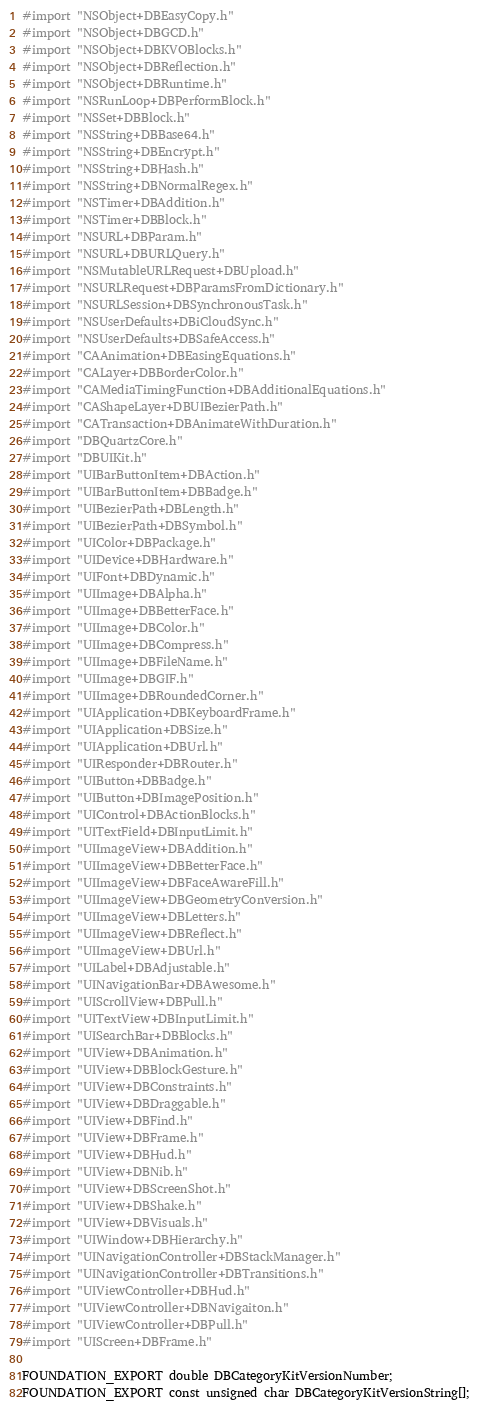<code> <loc_0><loc_0><loc_500><loc_500><_C_>#import "NSObject+DBEasyCopy.h"
#import "NSObject+DBGCD.h"
#import "NSObject+DBKVOBlocks.h"
#import "NSObject+DBReflection.h"
#import "NSObject+DBRuntime.h"
#import "NSRunLoop+DBPerformBlock.h"
#import "NSSet+DBBlock.h"
#import "NSString+DBBase64.h"
#import "NSString+DBEncrypt.h"
#import "NSString+DBHash.h"
#import "NSString+DBNormalRegex.h"
#import "NSTimer+DBAddition.h"
#import "NSTimer+DBBlock.h"
#import "NSURL+DBParam.h"
#import "NSURL+DBURLQuery.h"
#import "NSMutableURLRequest+DBUpload.h"
#import "NSURLRequest+DBParamsFromDictionary.h"
#import "NSURLSession+DBSynchronousTask.h"
#import "NSUserDefaults+DBiCloudSync.h"
#import "NSUserDefaults+DBSafeAccess.h"
#import "CAAnimation+DBEasingEquations.h"
#import "CALayer+DBBorderColor.h"
#import "CAMediaTimingFunction+DBAdditionalEquations.h"
#import "CAShapeLayer+DBUIBezierPath.h"
#import "CATransaction+DBAnimateWithDuration.h"
#import "DBQuartzCore.h"
#import "DBUIKit.h"
#import "UIBarButtonItem+DBAction.h"
#import "UIBarButtonItem+DBBadge.h"
#import "UIBezierPath+DBLength.h"
#import "UIBezierPath+DBSymbol.h"
#import "UIColor+DBPackage.h"
#import "UIDevice+DBHardware.h"
#import "UIFont+DBDynamic.h"
#import "UIImage+DBAlpha.h"
#import "UIImage+DBBetterFace.h"
#import "UIImage+DBColor.h"
#import "UIImage+DBCompress.h"
#import "UIImage+DBFileName.h"
#import "UIImage+DBGIF.h"
#import "UIImage+DBRoundedCorner.h"
#import "UIApplication+DBKeyboardFrame.h"
#import "UIApplication+DBSize.h"
#import "UIApplication+DBUrl.h"
#import "UIResponder+DBRouter.h"
#import "UIButton+DBBadge.h"
#import "UIButton+DBImagePosition.h"
#import "UIControl+DBActionBlocks.h"
#import "UITextField+DBInputLimit.h"
#import "UIImageView+DBAddition.h"
#import "UIImageView+DBBetterFace.h"
#import "UIImageView+DBFaceAwareFill.h"
#import "UIImageView+DBGeometryConversion.h"
#import "UIImageView+DBLetters.h"
#import "UIImageView+DBReflect.h"
#import "UIImageView+DBUrl.h"
#import "UILabel+DBAdjustable.h"
#import "UINavigationBar+DBAwesome.h"
#import "UIScrollView+DBPull.h"
#import "UITextView+DBInputLimit.h"
#import "UISearchBar+DBBlocks.h"
#import "UIView+DBAnimation.h"
#import "UIView+DBBlockGesture.h"
#import "UIView+DBConstraints.h"
#import "UIView+DBDraggable.h"
#import "UIView+DBFind.h"
#import "UIView+DBFrame.h"
#import "UIView+DBHud.h"
#import "UIView+DBNib.h"
#import "UIView+DBScreenShot.h"
#import "UIView+DBShake.h"
#import "UIView+DBVisuals.h"
#import "UIWindow+DBHierarchy.h"
#import "UINavigationController+DBStackManager.h"
#import "UINavigationController+DBTransitions.h"
#import "UIViewController+DBHud.h"
#import "UIViewController+DBNavigaiton.h"
#import "UIViewController+DBPull.h"
#import "UIScreen+DBFrame.h"

FOUNDATION_EXPORT double DBCategoryKitVersionNumber;
FOUNDATION_EXPORT const unsigned char DBCategoryKitVersionString[];

</code> 